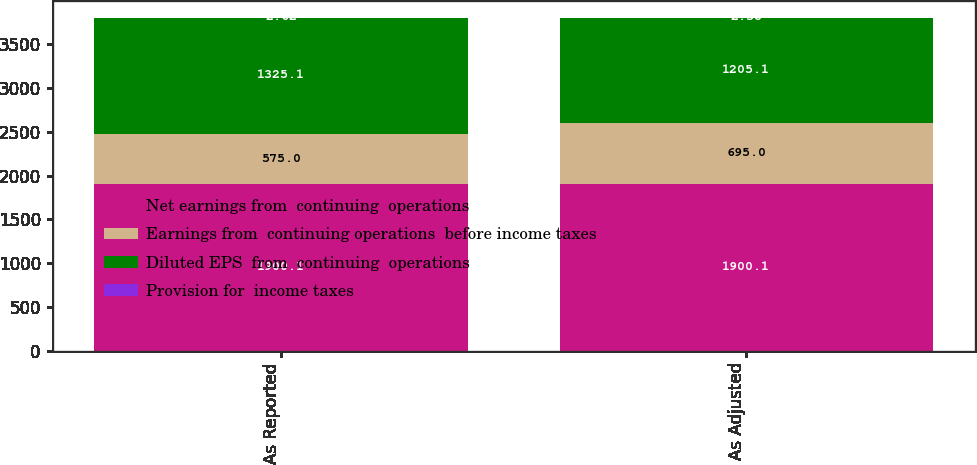Convert chart to OTSL. <chart><loc_0><loc_0><loc_500><loc_500><stacked_bar_chart><ecel><fcel>As Reported<fcel>As Adjusted<nl><fcel>Net earnings from  continuing  operations<fcel>1900.1<fcel>1900.1<nl><fcel>Earnings from  continuing operations  before income taxes<fcel>575<fcel>695<nl><fcel>Diluted EPS  from  continuing  operations<fcel>1325.1<fcel>1205.1<nl><fcel>Provision for  income taxes<fcel>2.62<fcel>2.38<nl></chart> 